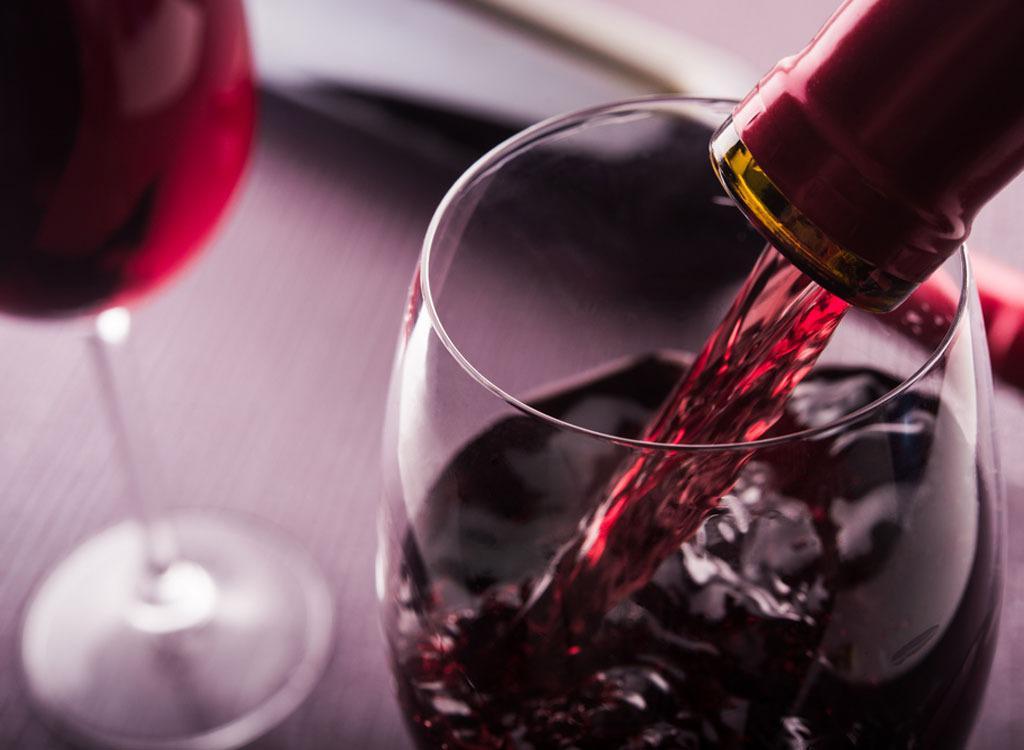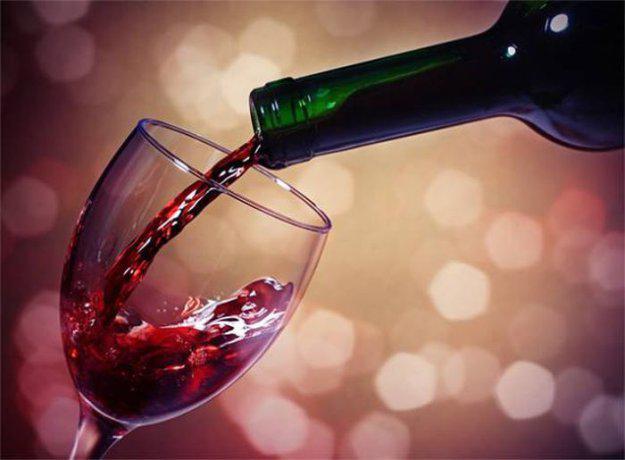The first image is the image on the left, the second image is the image on the right. Assess this claim about the two images: "Wine is pouring from a bottle into a glass in the right image.". Correct or not? Answer yes or no. Yes. 